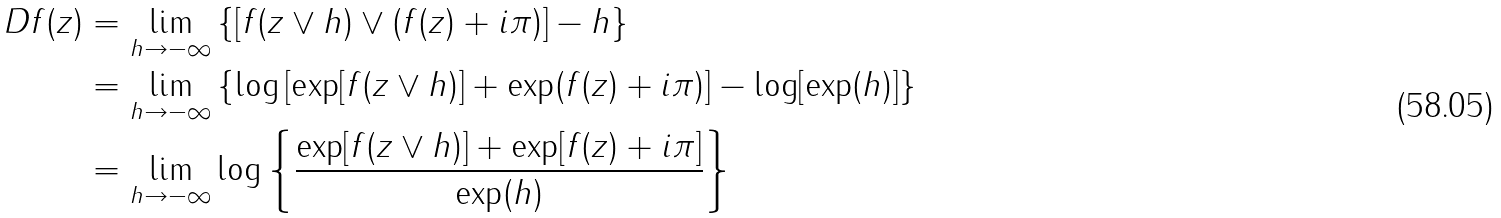<formula> <loc_0><loc_0><loc_500><loc_500>D f ( z ) & = \lim _ { h \rightarrow - \infty } \left \{ \left [ f ( z \vee h ) \vee ( f ( z ) + i \pi ) \right ] - h \right \} \\ & = \lim _ { h \rightarrow - \infty } \left \{ \log \left [ \exp [ f ( z \vee h ) ] + \exp ( f ( z ) + i \pi ) \right ] - \log [ \exp ( h ) ] \right \} \\ & = \lim _ { h \rightarrow - \infty } \log \left \{ \frac { \exp [ f ( z \vee h ) ] + \exp [ f ( z ) + i \pi ] } { \exp ( h ) } \right \}</formula> 